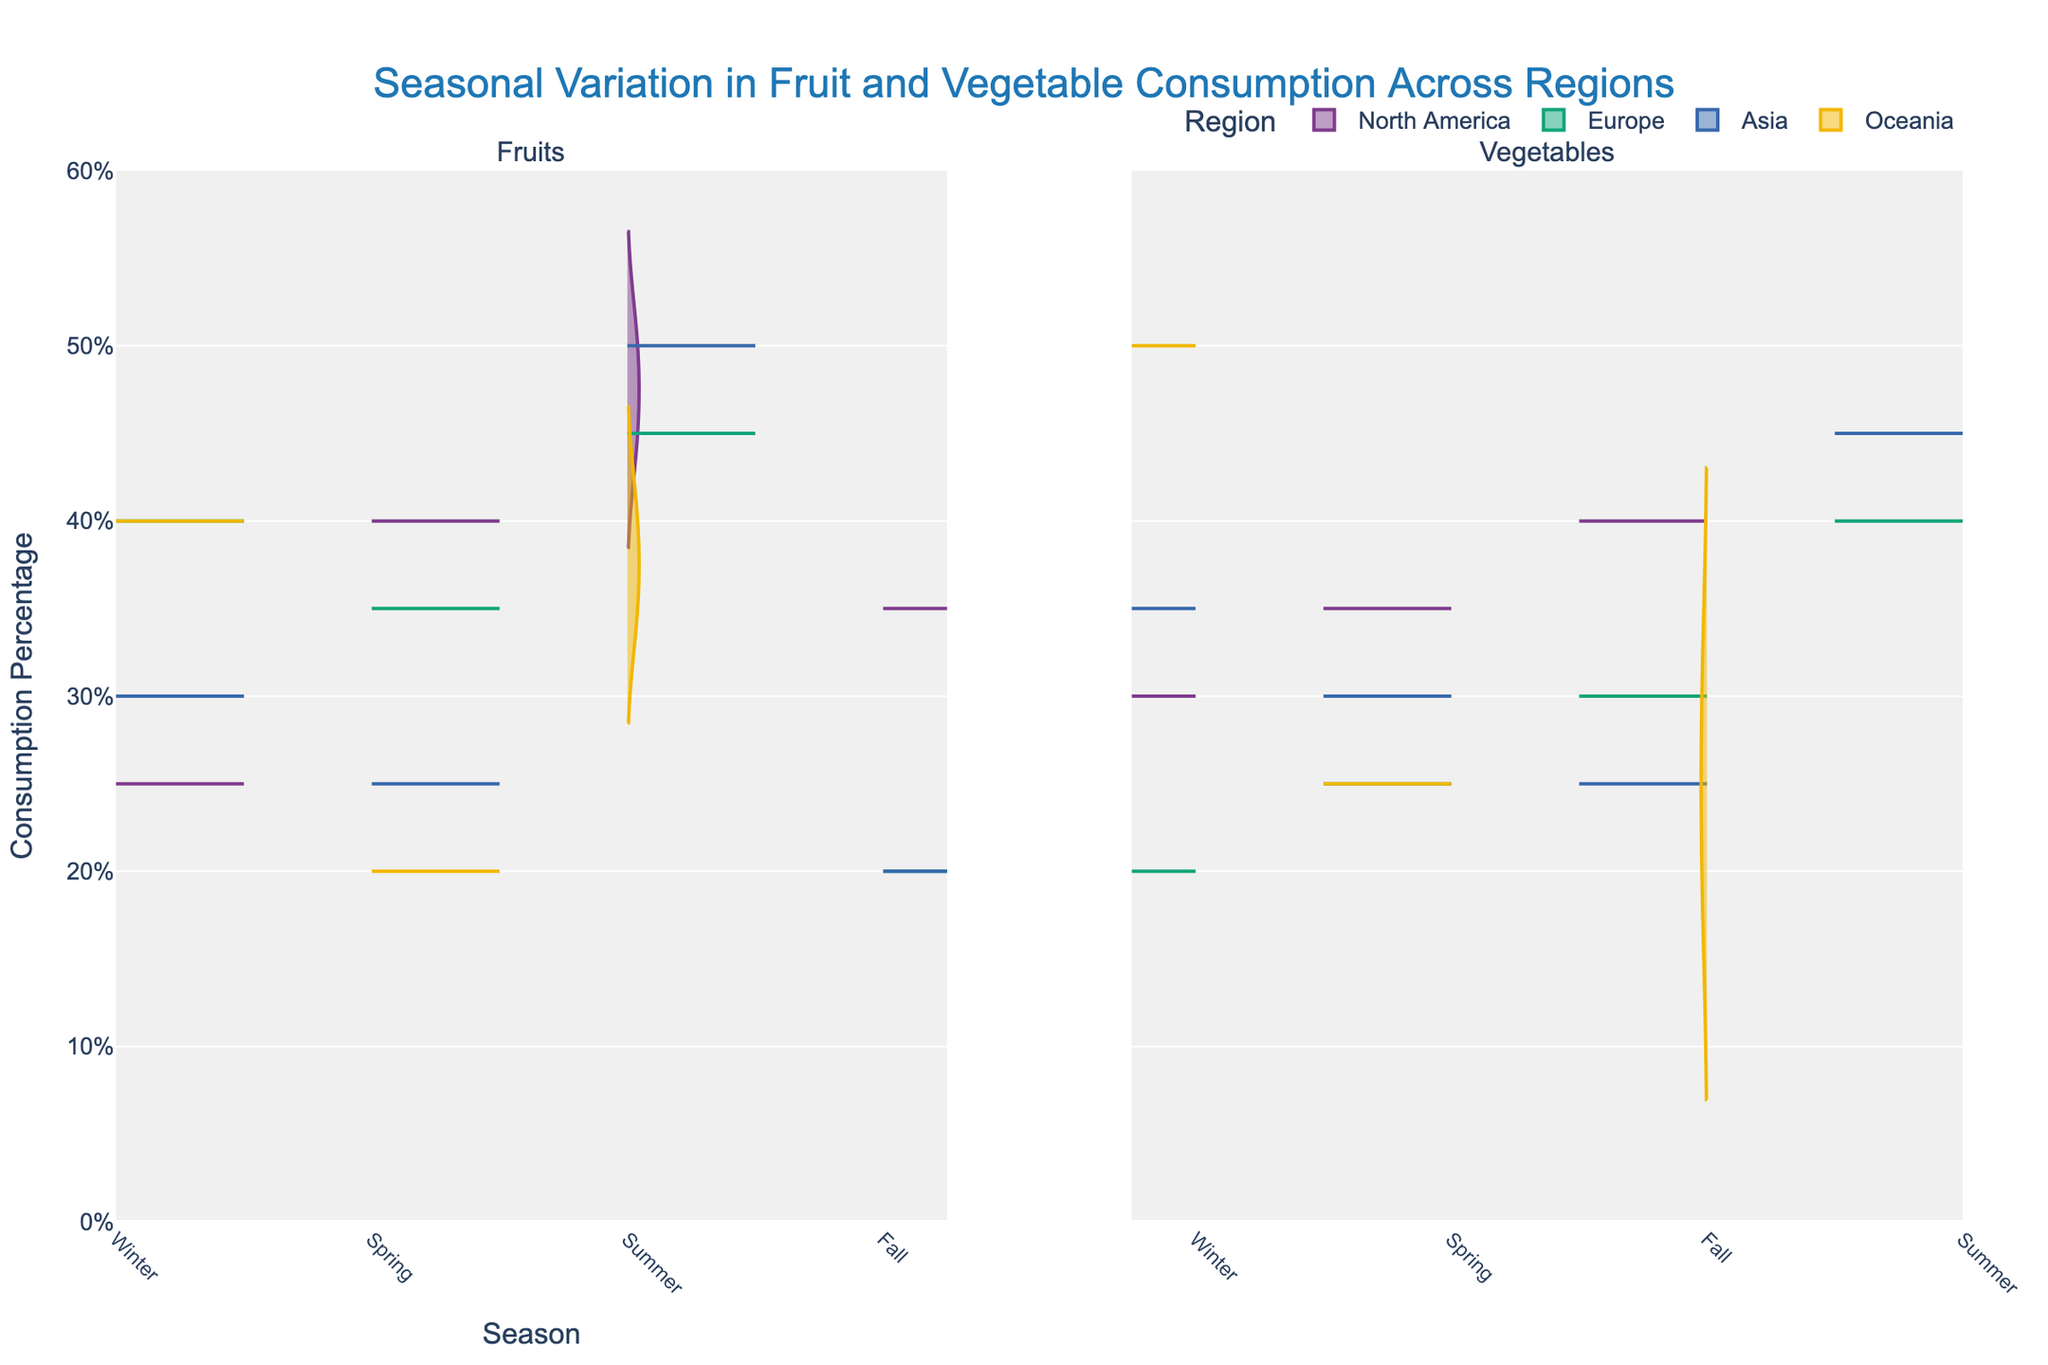What regions are being compared in the chart? The chart displays different regions for comparison, including North America, Europe, Asia, and Oceania. These regions are identified in the legend.
Answer: North America, Europe, Asia, Oceania What is the title of the chart? The title of the chart is presented prominently at the top of the plot, stating "Seasonal Variation in Fruit and Vegetable Consumption Across Regions".
Answer: Seasonal Variation in Fruit and Vegetable Consumption Across Regions Which season in North America has the highest fruit consumption percentage? Observing the right side, representing fruit consumption in North America, summer shows the highest consumption percentage, with Peaches at 50%.
Answer: Summer What is the average consumption percentage of vegetables in Europe during the fall season? In the fall, Broccoli and Apples are mentioned for Europe, with consumption percentages of 30% and 20%. Averaging these values: (30 + 20) / 2 = 25.
Answer: 25% Is vegetable consumption higher in Asia during winter compared to spring? For Asia, winter vegetables (Cabbage at 35%) compare against spring vegetables (Green_Peas at 30%). Winter consumption (35%) is indeed higher than spring (30%).
Answer: Yes Which region consumes the highest percentage of winter vegetables, and what is that percentage? By examining winter vegetable consumption across regions on the chart's left side, Oceania consumes the highest percentage with Potatoes at 50%.
Answer: Oceania, 50% Are summer fruit consumption percentages in Asia and Europe equal? By looking at the summer fruit regions on the left side, Asia's Mangoes at 50% and Europe's Cherries at 45%. They are not equal; Asia's is higher.
Answer: No What regions consume Tomatoes, and what season is it most consumed? North America is the sole region consuming Tomatoes during the summer season, with a percentage consumption of 45%.
Answer: North America, Summer Are there any regions that consume Radishes, and if so, in which seasons? Radishes appear only in the Asia region during the fall season, as seen in the vegetable consumption section of the chart.
Answer: Yes, Fall Which season shows the lowest average fruit consumption across all regions? Summarizing fruit consumption percentages across all regions for each season: Winter (North America: 25+30, Europe: 40+20, Asia: 30+35, Oceania: 40+50), Spring (North America: 40+35, Europe: 25+35, Asia: 25+30, Oceania: 20+25), Summer (North America: 45+50, Europe: 40+45, Asia: 50+45, Oceania: 35+40), Fall (North America: 35+40, Europe: 30+20, Asia: 20+25, Oceania: 20+30). The average of these seasons suggests winter is the lowest. Calculations confirm winter averages as lowest.
Answer: Winter 